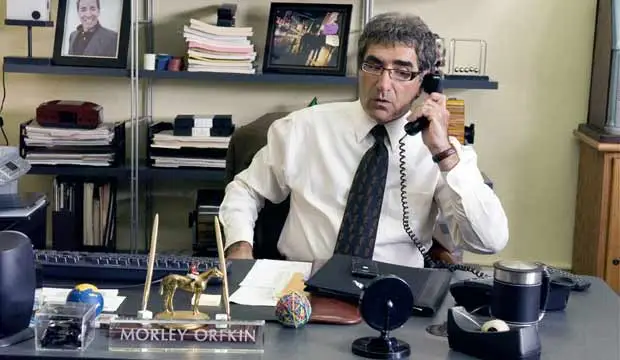What is this photo about? The photo showcases an actor, seemingly in character, seated at a busy desk while engaged in a phone conversation. The setting is an office, indicated by items like a gold camel statue, a black desk lamp, and stacks of papers which signify a workspace. The man's professional attire, featuring a white shirt and striped tie, suits the office environment. Notably, a framed photo on the wall and a visible nameplate reading 'Morley Orkin' hint that this character might hold a significant position or identity within the narrative presented. 